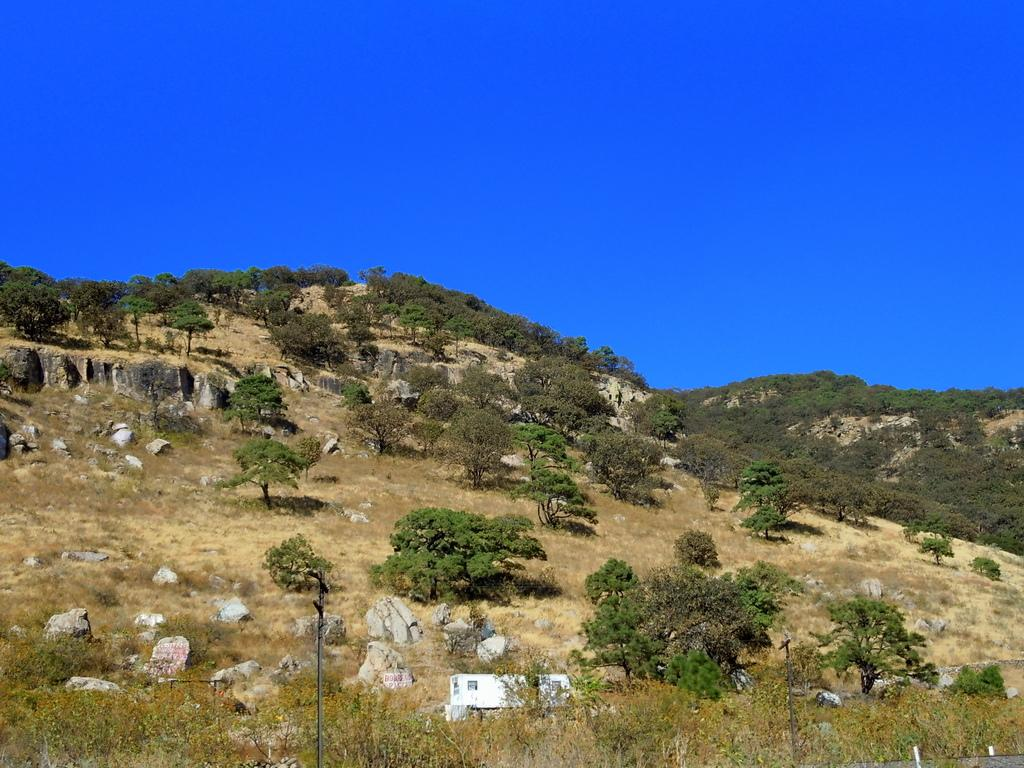What type of landscape is depicted in the image? There is a hill view in the image. What can be seen on the hill? There are plants and stones on the hill. What is located at the bottom of the hill? There is a pole at the bottom of the hill. What is visible at the top of the hill? The sky is visible at the top of the hill. How many nuts are being cracked by the squirrel on the hill? There is no squirrel or nuts present in the image. Is the hill hot or cold in the image? The image does not provide information about the temperature of the hill, so it cannot be determined if it is hot or cold. 